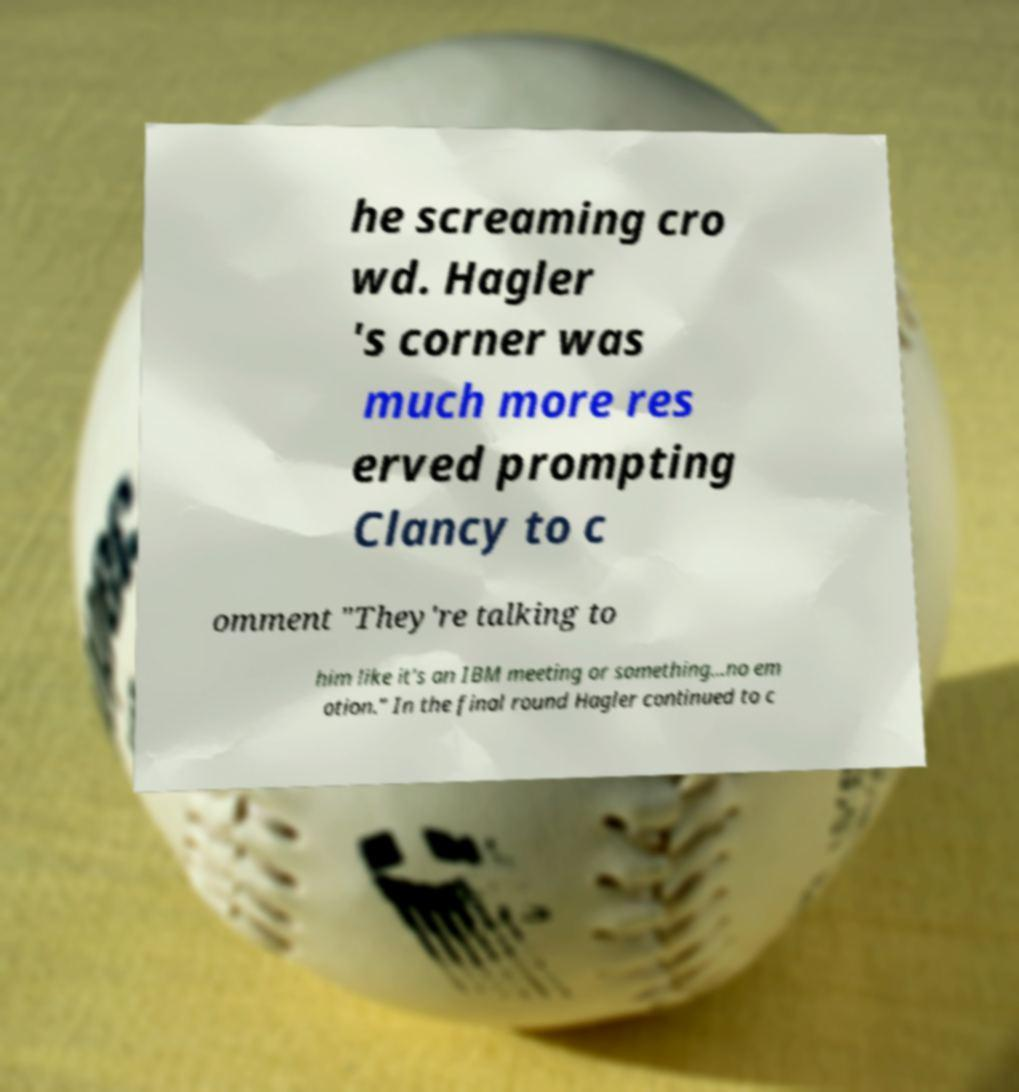Please read and relay the text visible in this image. What does it say? he screaming cro wd. Hagler 's corner was much more res erved prompting Clancy to c omment "They're talking to him like it's an IBM meeting or something...no em otion." In the final round Hagler continued to c 